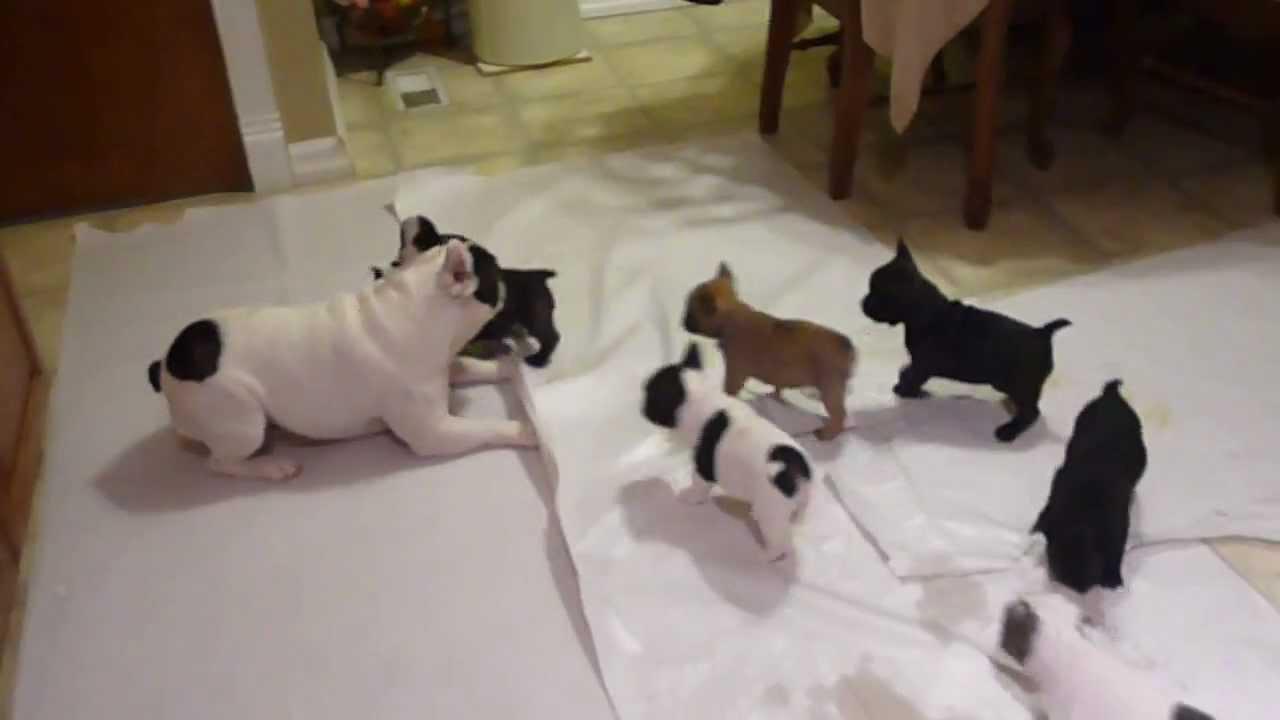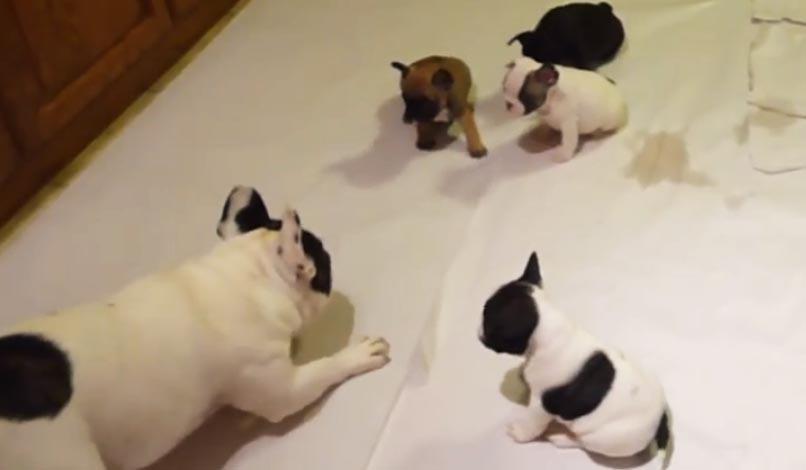The first image is the image on the left, the second image is the image on the right. Considering the images on both sides, is "One of the images shows exactly two dogs." valid? Answer yes or no. No. The first image is the image on the left, the second image is the image on the right. For the images shown, is this caption "An image shows exactly two real puppies." true? Answer yes or no. No. 